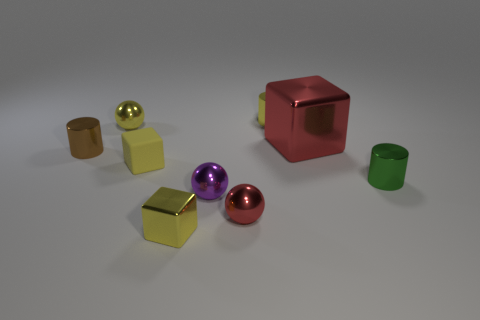How many tiny spheres are behind the small red object and in front of the green metal thing?
Offer a very short reply. 1. What number of small yellow things are in front of the thing behind the small sphere that is on the left side of the rubber block?
Offer a terse response. 3. The metal ball that is the same color as the large shiny cube is what size?
Offer a terse response. Small. The tiny brown shiny object has what shape?
Your answer should be very brief. Cylinder. What number of large red blocks have the same material as the small purple sphere?
Ensure brevity in your answer.  1. The large object that is the same material as the small brown cylinder is what color?
Offer a terse response. Red. Does the brown cylinder have the same size as the red metal object behind the small green metal cylinder?
Provide a succinct answer. No. What material is the sphere on the left side of the metallic cube in front of the red ball that is on the right side of the small rubber cube made of?
Provide a succinct answer. Metal. How many objects are blue cubes or metal balls?
Make the answer very short. 3. There is a tiny cylinder that is left of the yellow cylinder; is its color the same as the sphere left of the tiny yellow rubber block?
Keep it short and to the point. No. 